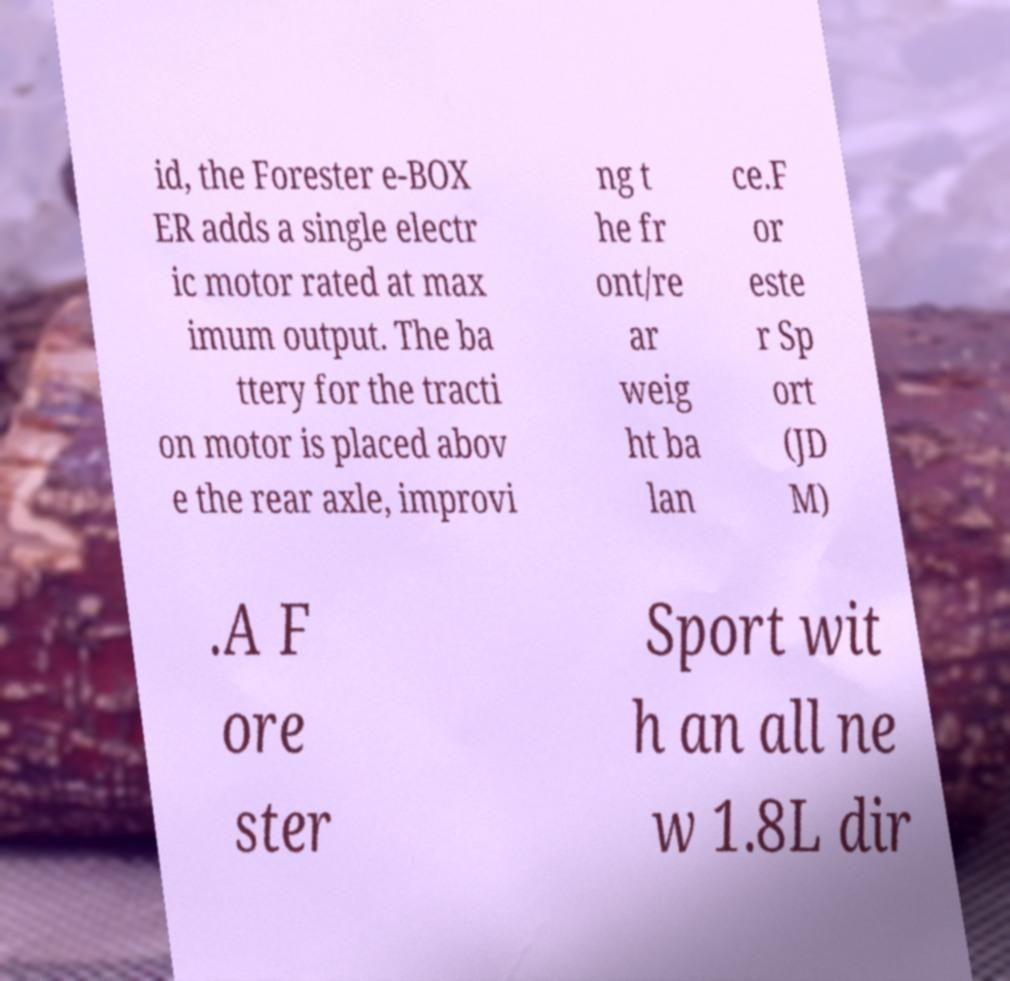Please read and relay the text visible in this image. What does it say? id, the Forester e-BOX ER adds a single electr ic motor rated at max imum output. The ba ttery for the tracti on motor is placed abov e the rear axle, improvi ng t he fr ont/re ar weig ht ba lan ce.F or este r Sp ort (JD M) .A F ore ster Sport wit h an all ne w 1.8L dir 